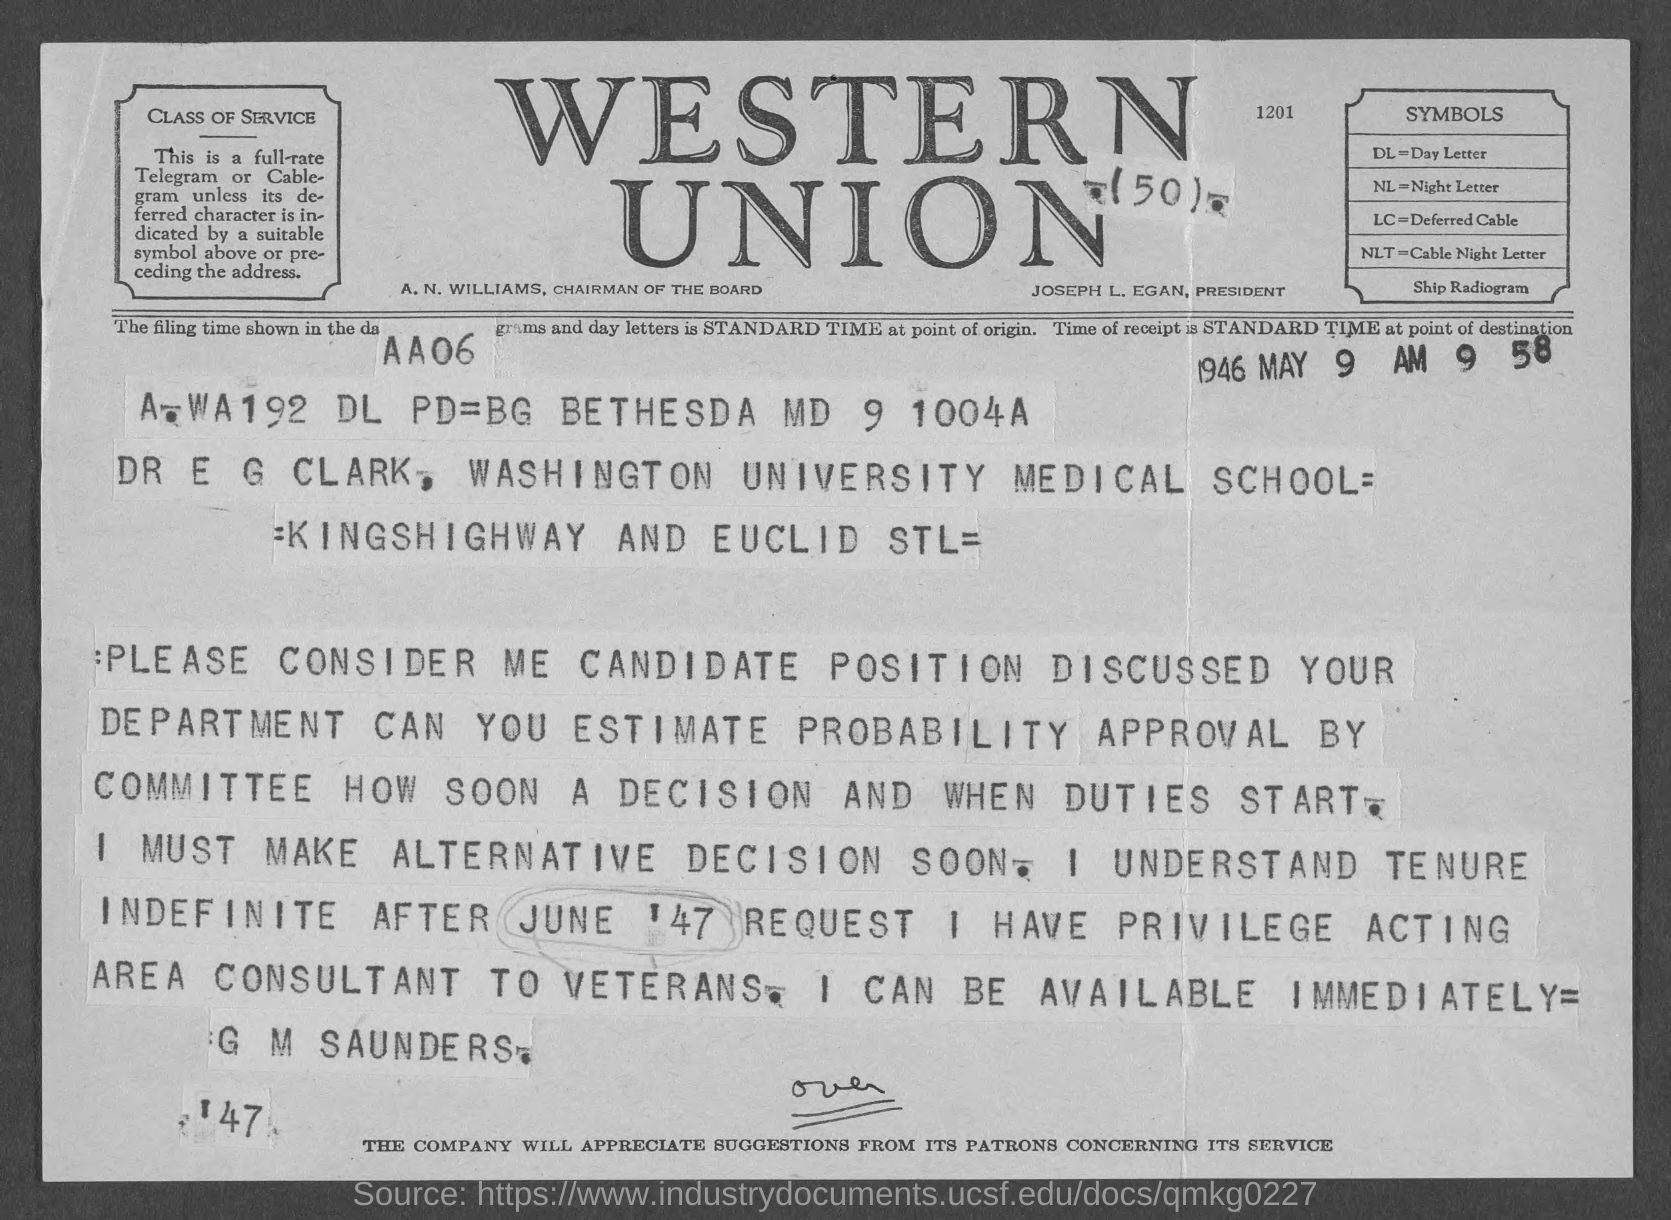Identify some key points in this picture. I, [name], declare that the symbol DL stands for Day Letter. Who is the President? The President's name is JOSEPH L. EGAN. The term "NLT" refers to Cable Night Letter. Western Union is the firm that is mentioned at the top of the page. A. N. Williams is the Chairman of the Board. 